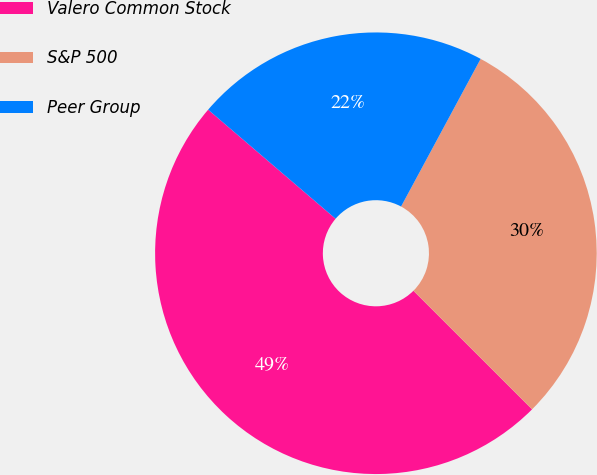Convert chart. <chart><loc_0><loc_0><loc_500><loc_500><pie_chart><fcel>Valero Common Stock<fcel>S&P 500<fcel>Peer Group<nl><fcel>48.77%<fcel>29.63%<fcel>21.6%<nl></chart> 